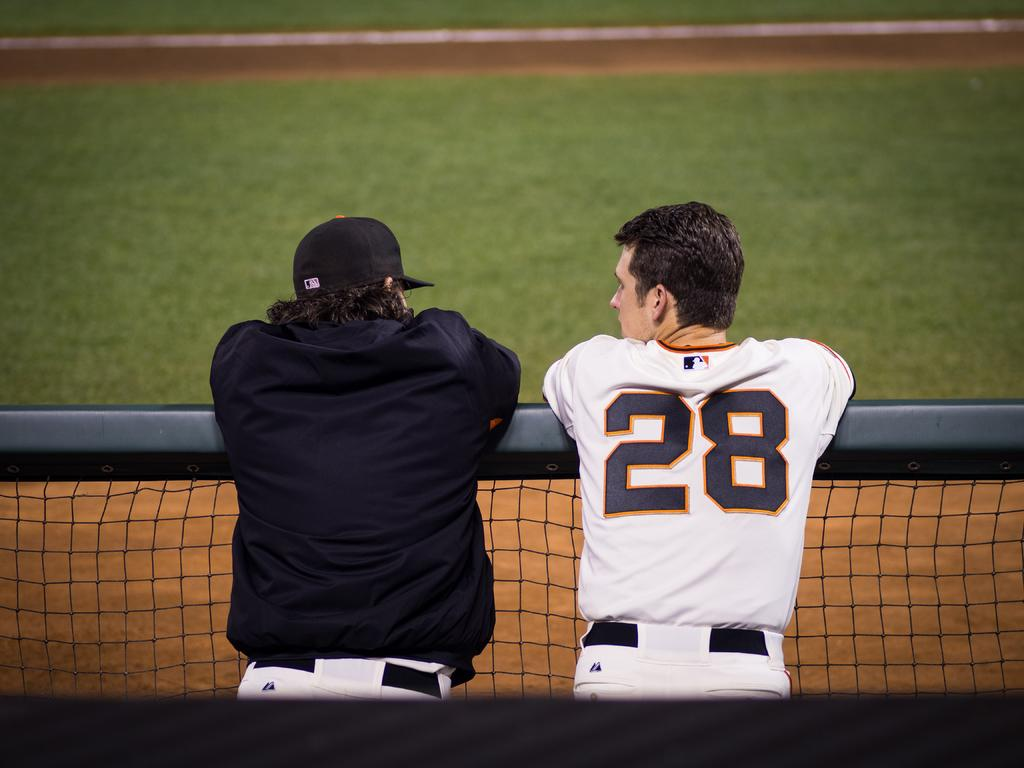<image>
Offer a succinct explanation of the picture presented. player number 28 leaning on rail with another player 